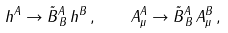Convert formula to latex. <formula><loc_0><loc_0><loc_500><loc_500>h ^ { A } \to \tilde { B } ^ { A } _ { \, B } \, h ^ { B } \, , \quad A ^ { A } _ { \mu } \to \tilde { B } ^ { A } _ { \, B } \, A ^ { B } _ { \mu } \, ,</formula> 